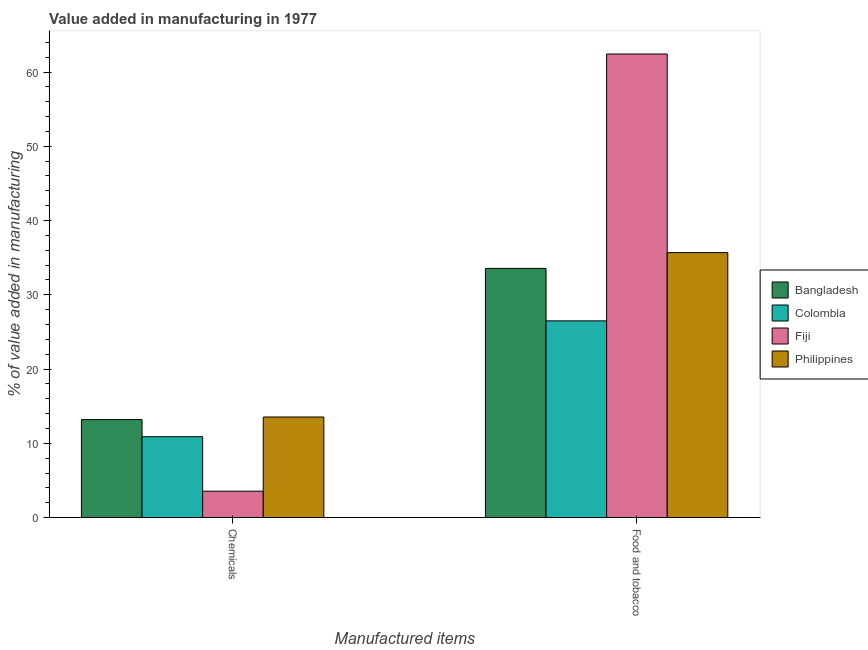How many groups of bars are there?
Give a very brief answer. 2. Are the number of bars per tick equal to the number of legend labels?
Your response must be concise. Yes. How many bars are there on the 2nd tick from the right?
Offer a terse response. 4. What is the label of the 1st group of bars from the left?
Your response must be concise. Chemicals. What is the value added by  manufacturing chemicals in Fiji?
Your answer should be very brief. 3.55. Across all countries, what is the maximum value added by  manufacturing chemicals?
Ensure brevity in your answer.  13.54. Across all countries, what is the minimum value added by  manufacturing chemicals?
Offer a terse response. 3.55. In which country was the value added by  manufacturing chemicals minimum?
Give a very brief answer. Fiji. What is the total value added by manufacturing food and tobacco in the graph?
Your response must be concise. 158.15. What is the difference between the value added by manufacturing food and tobacco in Bangladesh and that in Colombia?
Your response must be concise. 7.07. What is the difference between the value added by  manufacturing chemicals in Bangladesh and the value added by manufacturing food and tobacco in Philippines?
Ensure brevity in your answer.  -22.48. What is the average value added by  manufacturing chemicals per country?
Your response must be concise. 10.29. What is the difference between the value added by manufacturing food and tobacco and value added by  manufacturing chemicals in Colombia?
Offer a very short reply. 15.6. In how many countries, is the value added by manufacturing food and tobacco greater than 60 %?
Provide a succinct answer. 1. What is the ratio of the value added by manufacturing food and tobacco in Bangladesh to that in Fiji?
Your answer should be very brief. 0.54. Is the value added by  manufacturing chemicals in Fiji less than that in Colombia?
Provide a short and direct response. Yes. Are all the bars in the graph horizontal?
Your response must be concise. No. How many countries are there in the graph?
Ensure brevity in your answer.  4. What is the difference between two consecutive major ticks on the Y-axis?
Ensure brevity in your answer.  10. Does the graph contain any zero values?
Your answer should be compact. No. Does the graph contain grids?
Offer a terse response. No. Where does the legend appear in the graph?
Your response must be concise. Center right. How are the legend labels stacked?
Keep it short and to the point. Vertical. What is the title of the graph?
Ensure brevity in your answer.  Value added in manufacturing in 1977. What is the label or title of the X-axis?
Give a very brief answer. Manufactured items. What is the label or title of the Y-axis?
Offer a very short reply. % of value added in manufacturing. What is the % of value added in manufacturing of Bangladesh in Chemicals?
Provide a short and direct response. 13.19. What is the % of value added in manufacturing in Colombia in Chemicals?
Keep it short and to the point. 10.89. What is the % of value added in manufacturing in Fiji in Chemicals?
Offer a terse response. 3.55. What is the % of value added in manufacturing of Philippines in Chemicals?
Offer a very short reply. 13.54. What is the % of value added in manufacturing of Bangladesh in Food and tobacco?
Ensure brevity in your answer.  33.55. What is the % of value added in manufacturing of Colombia in Food and tobacco?
Ensure brevity in your answer.  26.49. What is the % of value added in manufacturing in Fiji in Food and tobacco?
Your response must be concise. 62.43. What is the % of value added in manufacturing of Philippines in Food and tobacco?
Your answer should be very brief. 35.68. Across all Manufactured items, what is the maximum % of value added in manufacturing in Bangladesh?
Offer a terse response. 33.55. Across all Manufactured items, what is the maximum % of value added in manufacturing in Colombia?
Keep it short and to the point. 26.49. Across all Manufactured items, what is the maximum % of value added in manufacturing of Fiji?
Make the answer very short. 62.43. Across all Manufactured items, what is the maximum % of value added in manufacturing of Philippines?
Give a very brief answer. 35.68. Across all Manufactured items, what is the minimum % of value added in manufacturing of Bangladesh?
Offer a terse response. 13.19. Across all Manufactured items, what is the minimum % of value added in manufacturing in Colombia?
Offer a terse response. 10.89. Across all Manufactured items, what is the minimum % of value added in manufacturing of Fiji?
Make the answer very short. 3.55. Across all Manufactured items, what is the minimum % of value added in manufacturing of Philippines?
Give a very brief answer. 13.54. What is the total % of value added in manufacturing in Bangladesh in the graph?
Your answer should be very brief. 46.75. What is the total % of value added in manufacturing in Colombia in the graph?
Your answer should be compact. 37.38. What is the total % of value added in manufacturing of Fiji in the graph?
Your answer should be compact. 65.98. What is the total % of value added in manufacturing in Philippines in the graph?
Provide a succinct answer. 49.22. What is the difference between the % of value added in manufacturing of Bangladesh in Chemicals and that in Food and tobacco?
Provide a succinct answer. -20.36. What is the difference between the % of value added in manufacturing of Colombia in Chemicals and that in Food and tobacco?
Provide a short and direct response. -15.6. What is the difference between the % of value added in manufacturing in Fiji in Chemicals and that in Food and tobacco?
Offer a very short reply. -58.88. What is the difference between the % of value added in manufacturing of Philippines in Chemicals and that in Food and tobacco?
Provide a succinct answer. -22.14. What is the difference between the % of value added in manufacturing of Bangladesh in Chemicals and the % of value added in manufacturing of Colombia in Food and tobacco?
Offer a terse response. -13.29. What is the difference between the % of value added in manufacturing of Bangladesh in Chemicals and the % of value added in manufacturing of Fiji in Food and tobacco?
Provide a short and direct response. -49.23. What is the difference between the % of value added in manufacturing in Bangladesh in Chemicals and the % of value added in manufacturing in Philippines in Food and tobacco?
Your answer should be very brief. -22.48. What is the difference between the % of value added in manufacturing of Colombia in Chemicals and the % of value added in manufacturing of Fiji in Food and tobacco?
Your answer should be very brief. -51.54. What is the difference between the % of value added in manufacturing of Colombia in Chemicals and the % of value added in manufacturing of Philippines in Food and tobacco?
Keep it short and to the point. -24.79. What is the difference between the % of value added in manufacturing of Fiji in Chemicals and the % of value added in manufacturing of Philippines in Food and tobacco?
Offer a very short reply. -32.13. What is the average % of value added in manufacturing in Bangladesh per Manufactured items?
Offer a terse response. 23.37. What is the average % of value added in manufacturing in Colombia per Manufactured items?
Offer a very short reply. 18.69. What is the average % of value added in manufacturing of Fiji per Manufactured items?
Give a very brief answer. 32.99. What is the average % of value added in manufacturing in Philippines per Manufactured items?
Ensure brevity in your answer.  24.61. What is the difference between the % of value added in manufacturing of Bangladesh and % of value added in manufacturing of Colombia in Chemicals?
Provide a succinct answer. 2.31. What is the difference between the % of value added in manufacturing in Bangladesh and % of value added in manufacturing in Fiji in Chemicals?
Keep it short and to the point. 9.64. What is the difference between the % of value added in manufacturing of Bangladesh and % of value added in manufacturing of Philippines in Chemicals?
Provide a short and direct response. -0.35. What is the difference between the % of value added in manufacturing in Colombia and % of value added in manufacturing in Fiji in Chemicals?
Offer a terse response. 7.34. What is the difference between the % of value added in manufacturing of Colombia and % of value added in manufacturing of Philippines in Chemicals?
Give a very brief answer. -2.65. What is the difference between the % of value added in manufacturing in Fiji and % of value added in manufacturing in Philippines in Chemicals?
Make the answer very short. -9.99. What is the difference between the % of value added in manufacturing of Bangladesh and % of value added in manufacturing of Colombia in Food and tobacco?
Give a very brief answer. 7.07. What is the difference between the % of value added in manufacturing in Bangladesh and % of value added in manufacturing in Fiji in Food and tobacco?
Your answer should be compact. -28.87. What is the difference between the % of value added in manufacturing in Bangladesh and % of value added in manufacturing in Philippines in Food and tobacco?
Offer a very short reply. -2.12. What is the difference between the % of value added in manufacturing of Colombia and % of value added in manufacturing of Fiji in Food and tobacco?
Your response must be concise. -35.94. What is the difference between the % of value added in manufacturing in Colombia and % of value added in manufacturing in Philippines in Food and tobacco?
Your answer should be very brief. -9.19. What is the difference between the % of value added in manufacturing in Fiji and % of value added in manufacturing in Philippines in Food and tobacco?
Offer a terse response. 26.75. What is the ratio of the % of value added in manufacturing in Bangladesh in Chemicals to that in Food and tobacco?
Provide a succinct answer. 0.39. What is the ratio of the % of value added in manufacturing of Colombia in Chemicals to that in Food and tobacco?
Keep it short and to the point. 0.41. What is the ratio of the % of value added in manufacturing in Fiji in Chemicals to that in Food and tobacco?
Your answer should be compact. 0.06. What is the ratio of the % of value added in manufacturing of Philippines in Chemicals to that in Food and tobacco?
Provide a succinct answer. 0.38. What is the difference between the highest and the second highest % of value added in manufacturing of Bangladesh?
Your answer should be very brief. 20.36. What is the difference between the highest and the second highest % of value added in manufacturing of Colombia?
Make the answer very short. 15.6. What is the difference between the highest and the second highest % of value added in manufacturing in Fiji?
Your response must be concise. 58.88. What is the difference between the highest and the second highest % of value added in manufacturing in Philippines?
Your answer should be very brief. 22.14. What is the difference between the highest and the lowest % of value added in manufacturing of Bangladesh?
Offer a very short reply. 20.36. What is the difference between the highest and the lowest % of value added in manufacturing of Colombia?
Keep it short and to the point. 15.6. What is the difference between the highest and the lowest % of value added in manufacturing of Fiji?
Provide a short and direct response. 58.88. What is the difference between the highest and the lowest % of value added in manufacturing in Philippines?
Offer a very short reply. 22.14. 